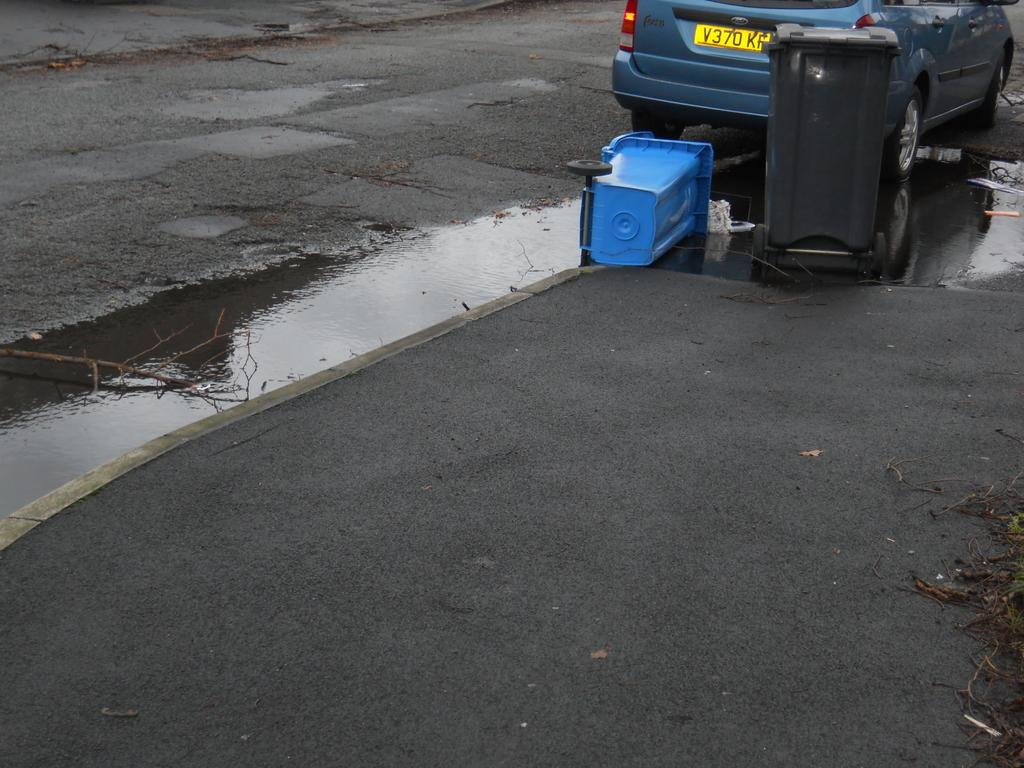What objects are present in the image that are used for waste disposal? There are dustbins in the image. What natural element is visible in the image? There is water visible in the image. What type of vehicle can be seen on the road in the image? There is a car on the road in the image. What type of haircut is being given to the car in the image? There is no haircut being given to the car in the image; it is a vehicle on the road. What industry is represented by the dustbins in the image? The image does not represent any specific industry; it simply shows the presence of dustbins. 